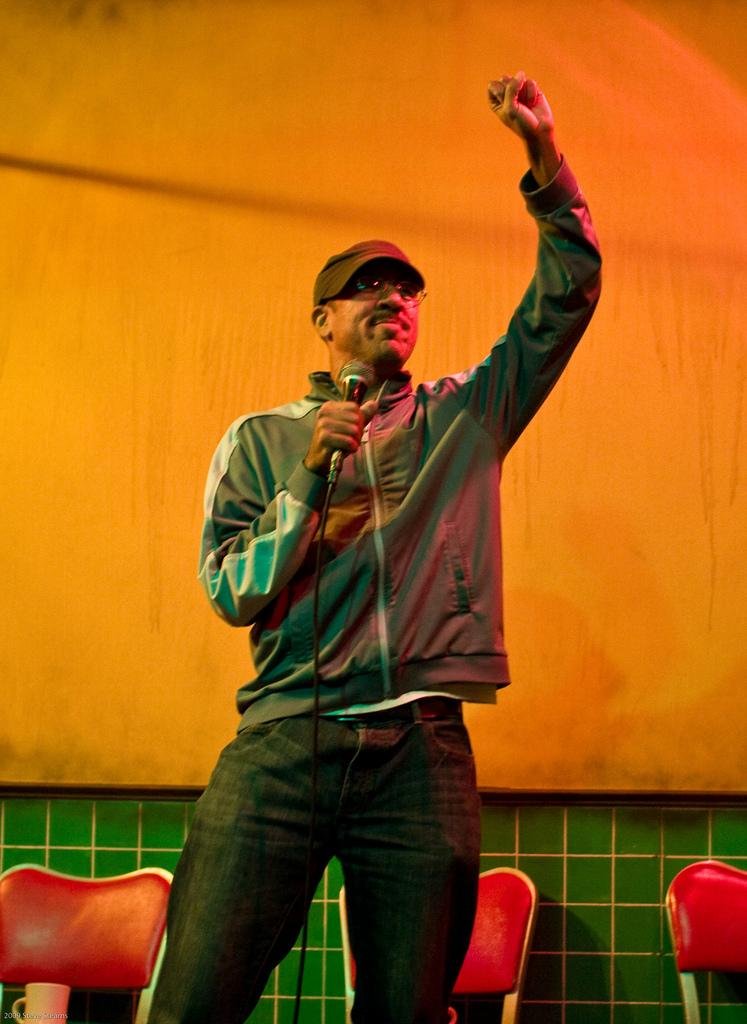Who is present in the image? There is a man in the image. What is the man wearing on his head? The man is wearing a cap. What accessory is the man wearing on his face? The man is wearing glasses (specs). What object is the man holding in his hand? The man is holding a microphone (mic). What can be seen in the background of the image? There are chairs and a wall in the background of the image. What is located at the bottom of the image? There is a cup at the bottom of the image. What type of gate can be seen in the image? There is no gate present in the image. What is the man using to stir the coffee in the cup? The man is not stirring coffee in the image, and there is no spoon present. 